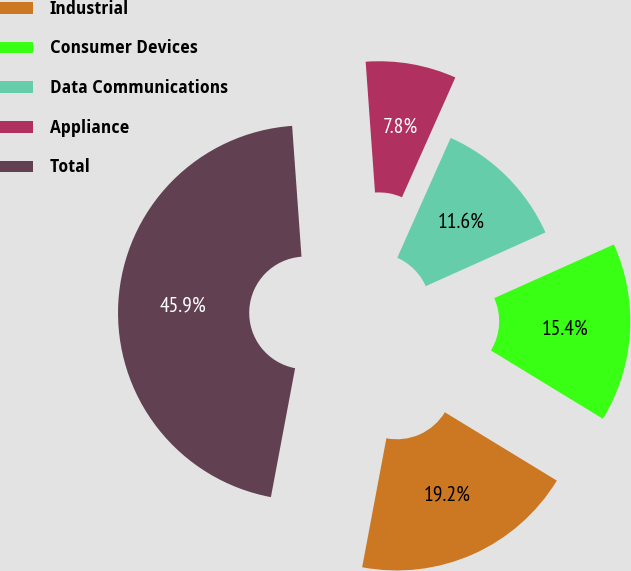Convert chart to OTSL. <chart><loc_0><loc_0><loc_500><loc_500><pie_chart><fcel>Industrial<fcel>Consumer Devices<fcel>Data Communications<fcel>Appliance<fcel>Total<nl><fcel>19.24%<fcel>15.43%<fcel>11.62%<fcel>7.81%<fcel>45.91%<nl></chart> 